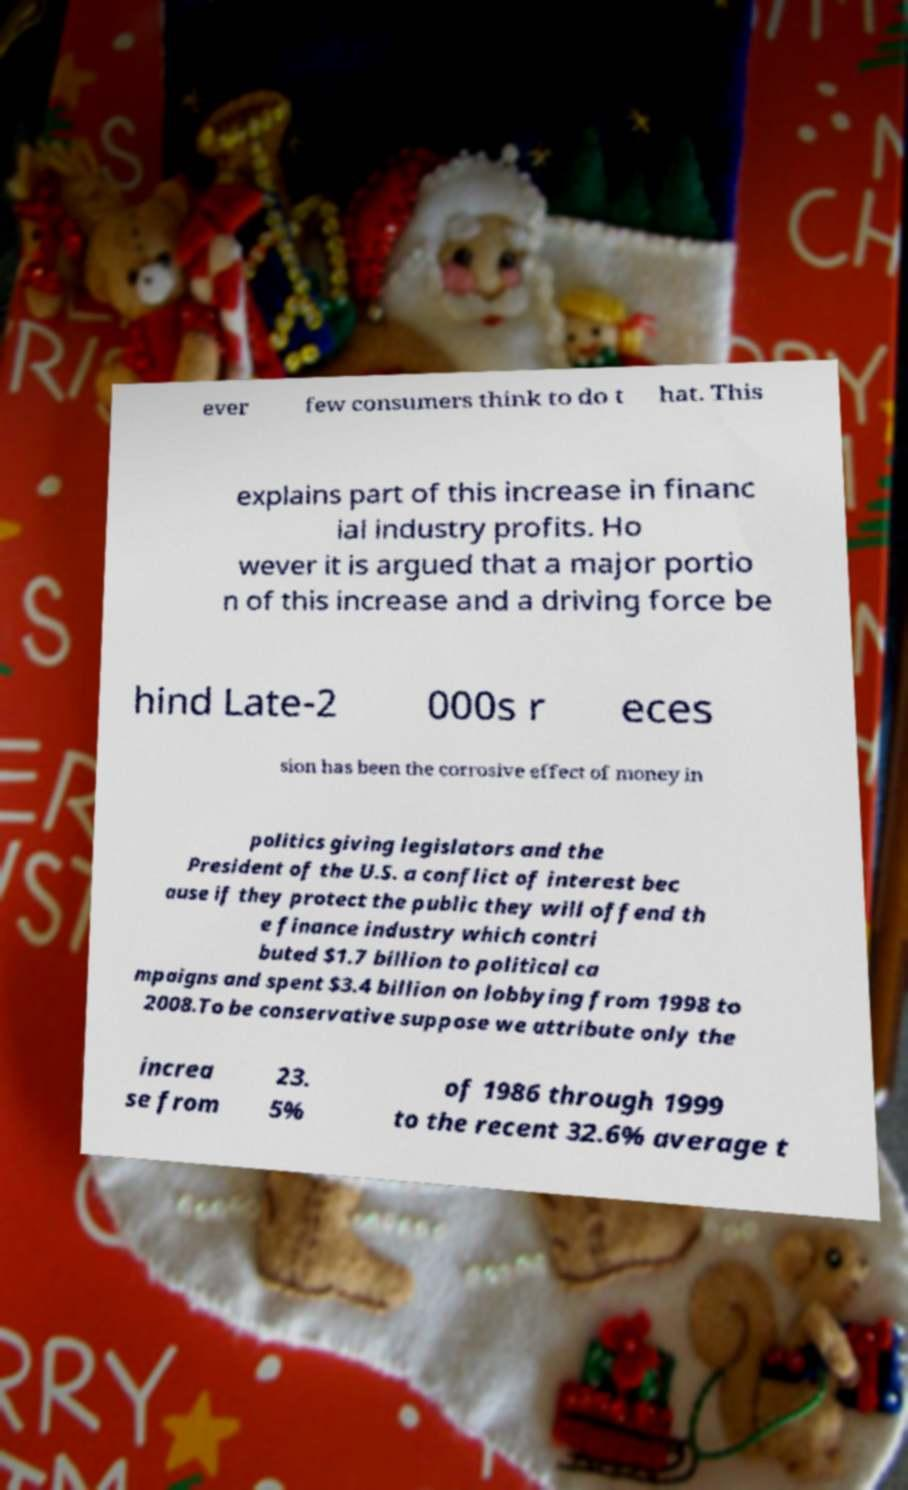For documentation purposes, I need the text within this image transcribed. Could you provide that? ever few consumers think to do t hat. This explains part of this increase in financ ial industry profits. Ho wever it is argued that a major portio n of this increase and a driving force be hind Late-2 000s r eces sion has been the corrosive effect of money in politics giving legislators and the President of the U.S. a conflict of interest bec ause if they protect the public they will offend th e finance industry which contri buted $1.7 billion to political ca mpaigns and spent $3.4 billion on lobbying from 1998 to 2008.To be conservative suppose we attribute only the increa se from 23. 5% of 1986 through 1999 to the recent 32.6% average t 